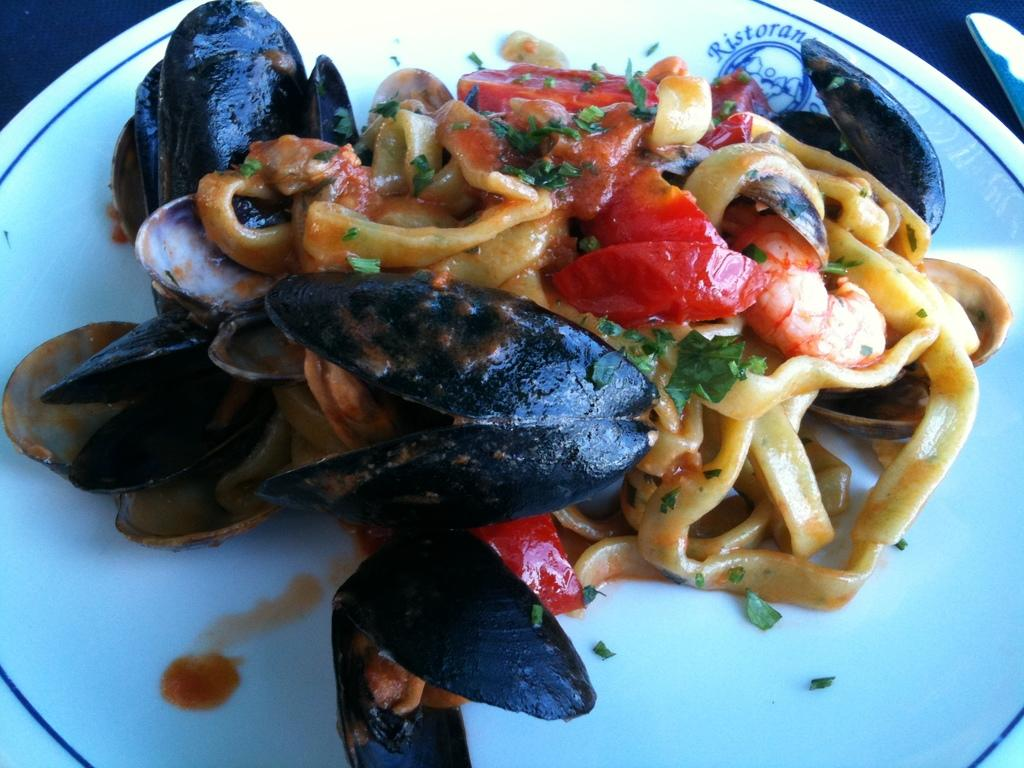What is on the plate that is visible in the image? There are food items on a plate in the image. What is the color of the plate? The plate is white in color. What can be seen in the background of the image? The background of the image is dark. How many people are in the crowd behind the plate in the image? There is no crowd present in the image; it only features a plate with food items. What type of truck can be seen parked next to the plate in the image? There is no truck present in the image; it only features a plate with food items. 